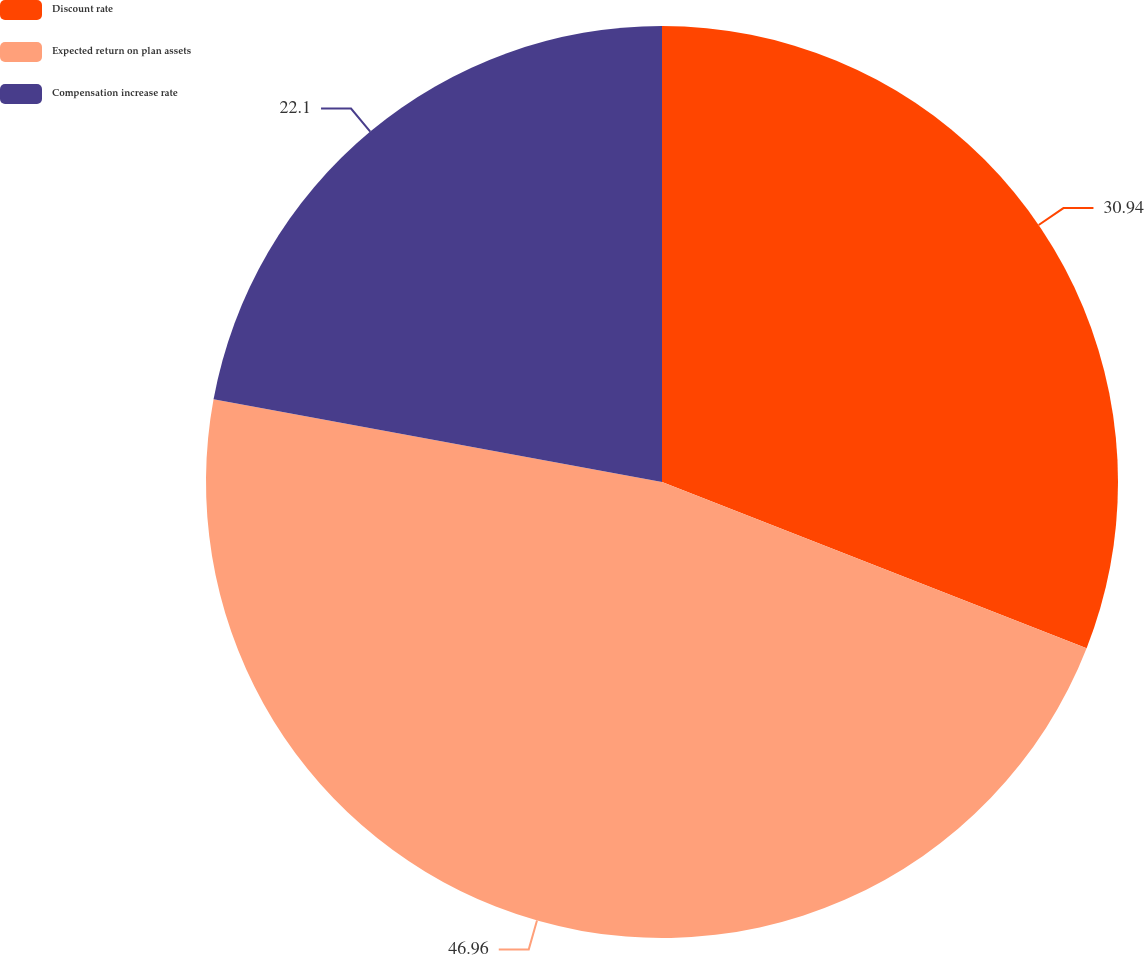Convert chart to OTSL. <chart><loc_0><loc_0><loc_500><loc_500><pie_chart><fcel>Discount rate<fcel>Expected return on plan assets<fcel>Compensation increase rate<nl><fcel>30.94%<fcel>46.96%<fcel>22.1%<nl></chart> 